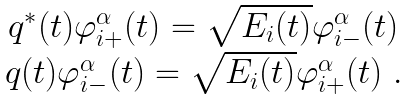<formula> <loc_0><loc_0><loc_500><loc_500>\begin{array} { c } q ^ { * } ( t ) \varphi _ { i + } ^ { \alpha } ( t ) = \sqrt { E _ { i } ( t ) } \varphi _ { i - } ^ { \alpha } ( t ) \\ q ( t ) \varphi _ { i - } ^ { \alpha } ( t ) = \sqrt { E _ { i } ( t ) } \varphi _ { i + } ^ { \alpha } ( t ) \ . \end{array}</formula> 